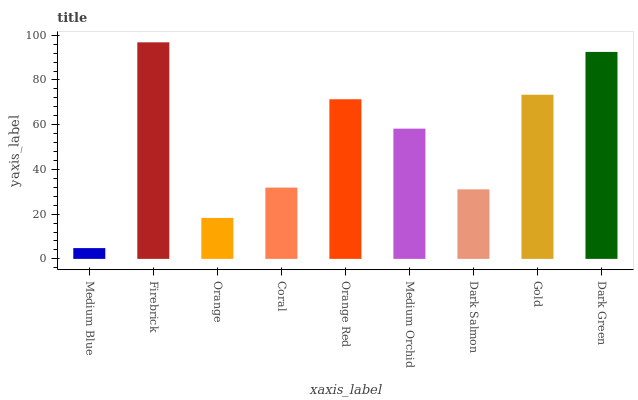Is Medium Blue the minimum?
Answer yes or no. Yes. Is Firebrick the maximum?
Answer yes or no. Yes. Is Orange the minimum?
Answer yes or no. No. Is Orange the maximum?
Answer yes or no. No. Is Firebrick greater than Orange?
Answer yes or no. Yes. Is Orange less than Firebrick?
Answer yes or no. Yes. Is Orange greater than Firebrick?
Answer yes or no. No. Is Firebrick less than Orange?
Answer yes or no. No. Is Medium Orchid the high median?
Answer yes or no. Yes. Is Medium Orchid the low median?
Answer yes or no. Yes. Is Orange Red the high median?
Answer yes or no. No. Is Firebrick the low median?
Answer yes or no. No. 